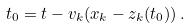<formula> <loc_0><loc_0><loc_500><loc_500>t _ { 0 } = t - v _ { k } ( x _ { k } - z _ { k } ( t _ { 0 } ) ) \, .</formula> 